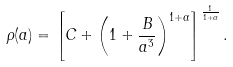<formula> <loc_0><loc_0><loc_500><loc_500>\rho ( a ) = \left [ C + \left ( 1 + \frac { B } { a ^ { 3 } } \right ) ^ { 1 + \alpha } \right ] ^ { \frac { 1 } { 1 + \alpha } } .</formula> 